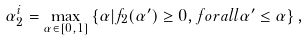<formula> <loc_0><loc_0><loc_500><loc_500>\alpha _ { 2 } ^ { i } = \underset { \alpha \in [ 0 , 1 ] } { \max } \left \{ \alpha | f _ { 2 } ( \alpha ^ { \prime } ) \geq 0 , f o r a l l \alpha ^ { \prime } \leq \alpha \right \} ,</formula> 